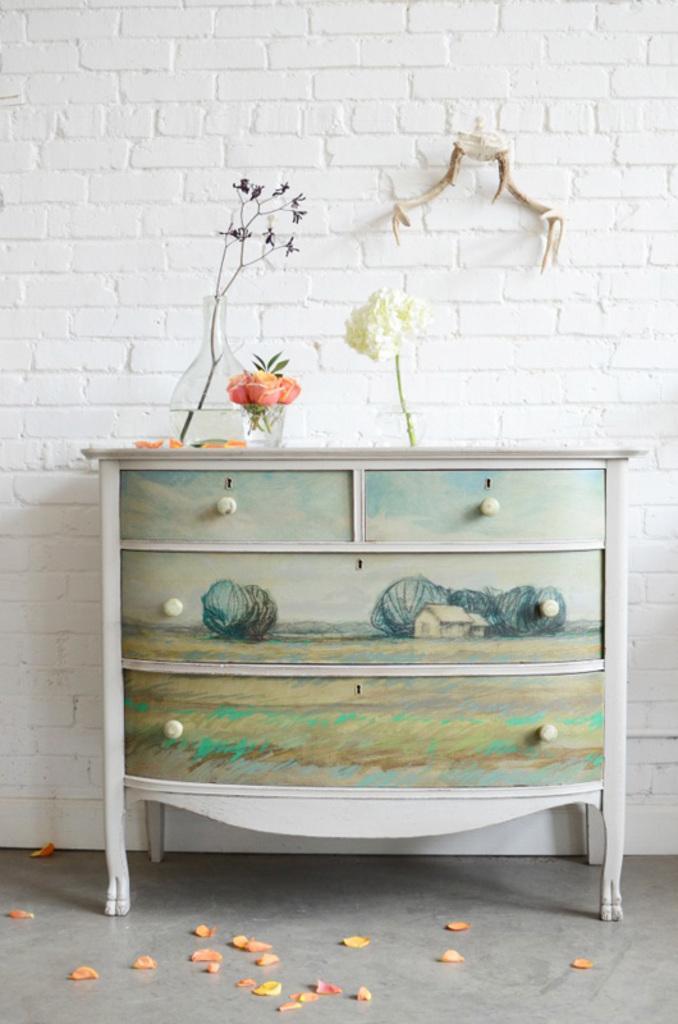In one or two sentences, can you explain what this image depicts? In the center of this picture we can see the flower vases are placed on the top of the cabinet and we can see the pictures of houses and pictures of some objects on the cabinet. In the background we can see the wall and some objects are lying on the floor. 